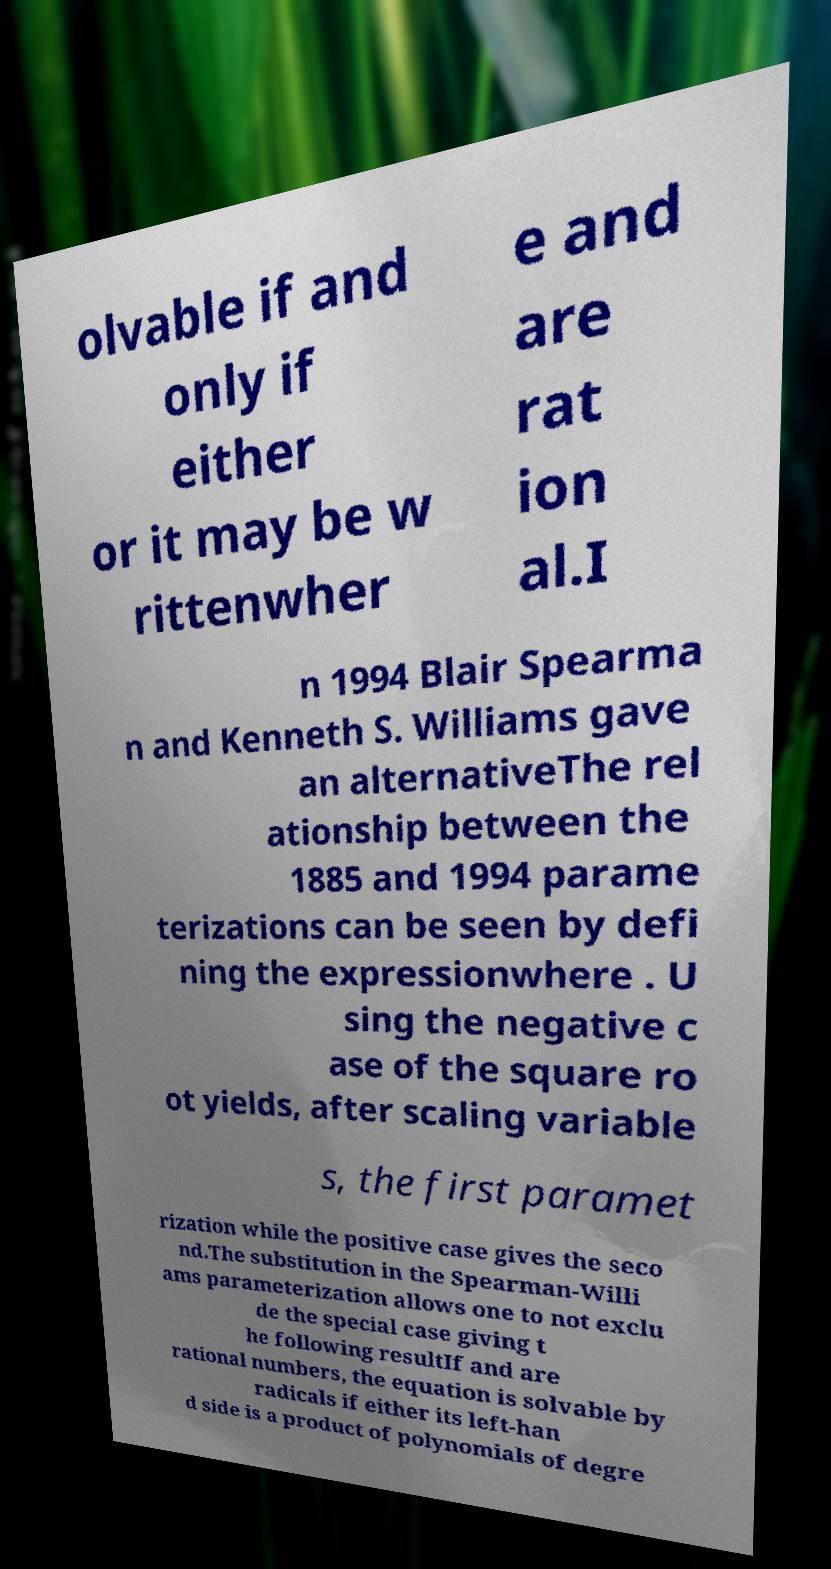What messages or text are displayed in this image? I need them in a readable, typed format. olvable if and only if either or it may be w rittenwher e and are rat ion al.I n 1994 Blair Spearma n and Kenneth S. Williams gave an alternativeThe rel ationship between the 1885 and 1994 parame terizations can be seen by defi ning the expressionwhere . U sing the negative c ase of the square ro ot yields, after scaling variable s, the first paramet rization while the positive case gives the seco nd.The substitution in the Spearman-Willi ams parameterization allows one to not exclu de the special case giving t he following resultIf and are rational numbers, the equation is solvable by radicals if either its left-han d side is a product of polynomials of degre 